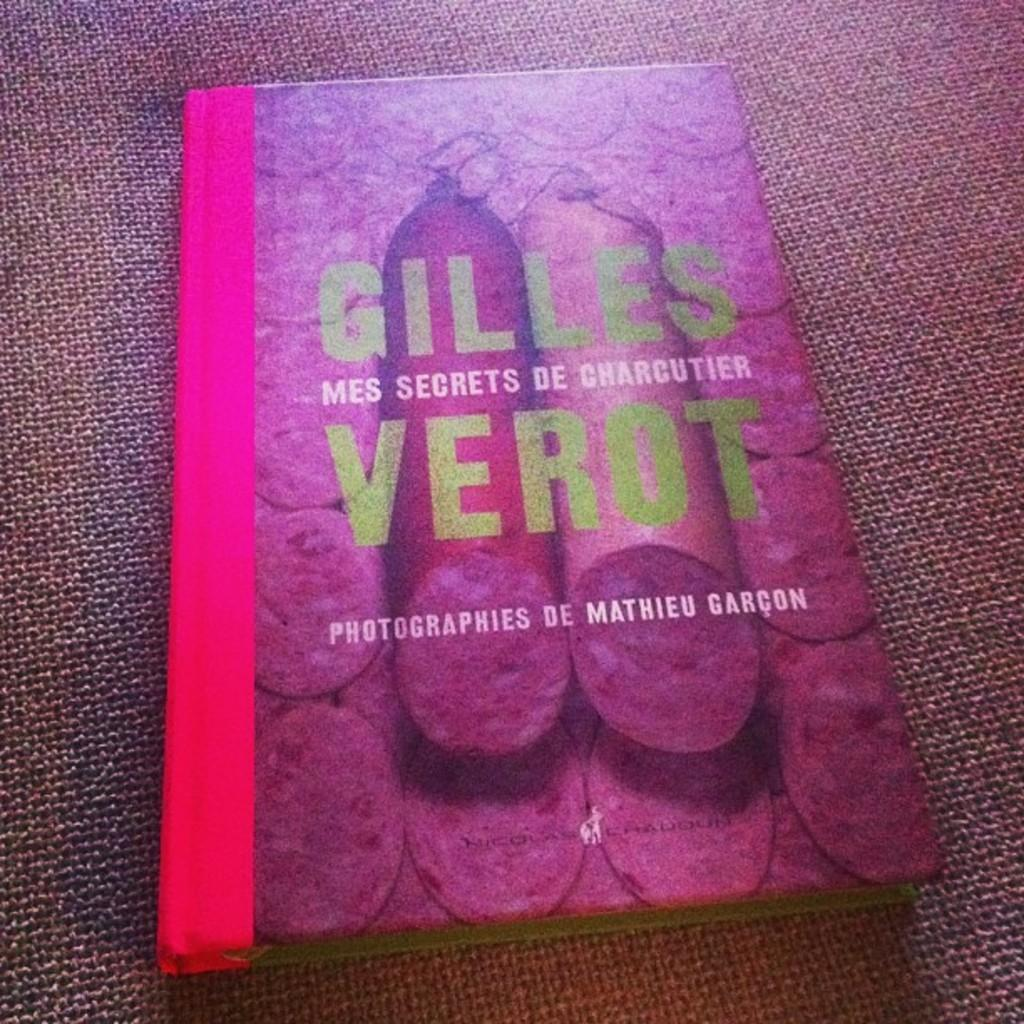Provide a one-sentence caption for the provided image. Gilles Verot's book is about charcuterie and has salami on the cover. 